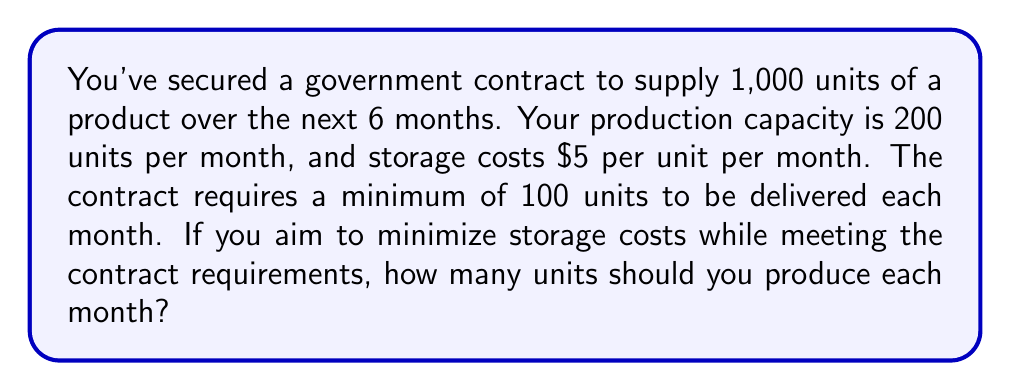Can you solve this math problem? Let's approach this step-by-step:

1) First, let's define our variables:
   $x$ = number of units produced each month

2) We know that over 6 months, we need to produce 1,000 units in total:
   $6x = 1000$

3) Solving for $x$:
   $x = \frac{1000}{6} \approx 166.67$

4) However, we can only produce whole units. We need to round up to ensure we meet the 1,000 unit requirement:
   $x = 167$ units per month

5) Let's verify if this meets the minimum monthly delivery requirement:
   167 > 100, so it does meet the minimum.

6) Let's also verify if this is within our production capacity:
   167 < 200, so it's within our capacity.

7) Finally, let's calculate the total production over 6 months:
   $167 * 6 = 1,002$ units

This slightly exceeds the contract requirement, but it's the minimum whole number of units per month that satisfies all constraints.
Answer: 167 units per month 